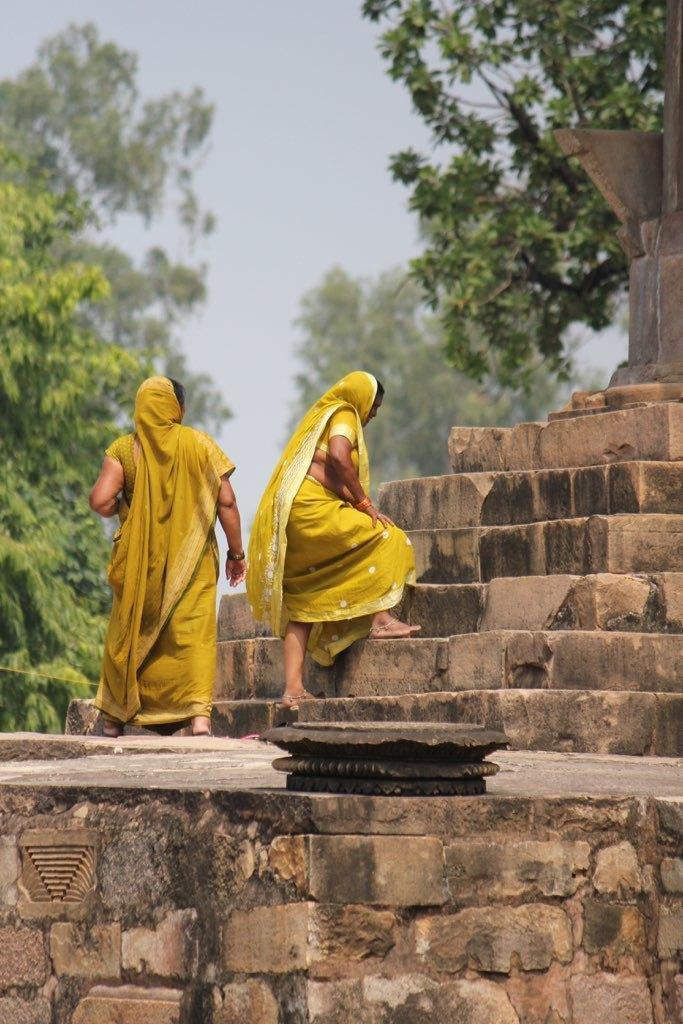Please provide a concise description of this image. In this image we can see two persons. Beside the persons we can see the stairs and a person is climbing the stairs. In the foreground we can see a wall. Behind the persons we can see trees and the sky. 